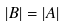<formula> <loc_0><loc_0><loc_500><loc_500>| B | = | A |</formula> 